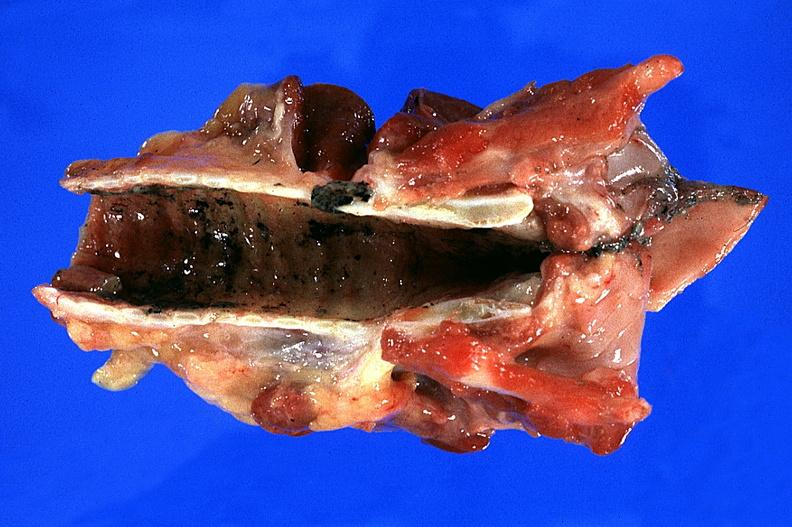what does this image show?
Answer the question using a single word or phrase. Trachea 